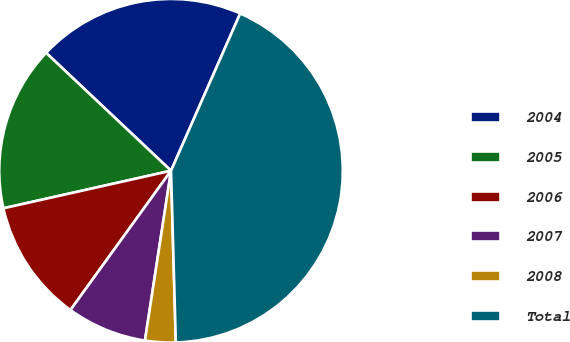<chart> <loc_0><loc_0><loc_500><loc_500><pie_chart><fcel>2004<fcel>2005<fcel>2006<fcel>2007<fcel>2008<fcel>Total<nl><fcel>19.56%<fcel>15.55%<fcel>11.54%<fcel>7.53%<fcel>2.87%<fcel>42.97%<nl></chart> 